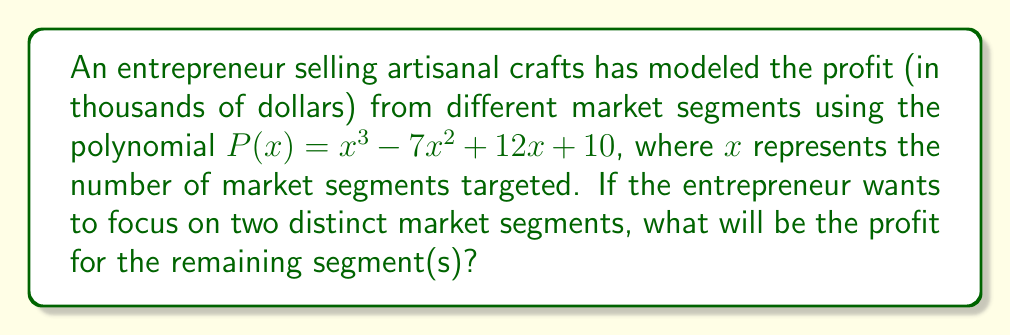Show me your answer to this math problem. To solve this problem, we need to follow these steps:

1) First, we need to factor the polynomial $P(x) = x^3 - 7x^2 + 12x + 10$. 

2) We can use the rational root theorem to find potential roots. The factors of the constant term (10) are ±1, ±2, ±5, ±10. 

3) Testing these values, we find that $x = 1$ and $x = 2$ are roots of the polynomial.

4) Using polynomial long division or synthetic division, we can factor out $(x-1)$ and $(x-2)$:

   $x^3 - 7x^2 + 12x + 10 = (x-1)(x-2)(x-4)$

5) The factored form of the polynomial is:

   $P(x) = (x-1)(x-2)(x-4)$

6) If the entrepreneur focuses on two distinct market segments, it means $x = 2$. We need to find $P(2)$:

   $P(2) = (2-1)(2-2)(2-4) = 1 \cdot 0 \cdot (-2) = 0$

7) This means that when focusing on two segments, the profit from these segments is 0.

8) The profit from the remaining segment(s) would be the total profit minus the profit from the two segments:

   $P(x) - P(2) = (x-1)(x-2)(x-4) - 0 = (x-1)(x-2)(x-4)$

Therefore, the profit for the remaining segment(s) is represented by $(x-1)(x-4)$ thousand dollars, or $x^2 - 5x + 4$ thousand dollars.
Answer: $x^2 - 5x + 4$ thousand dollars 